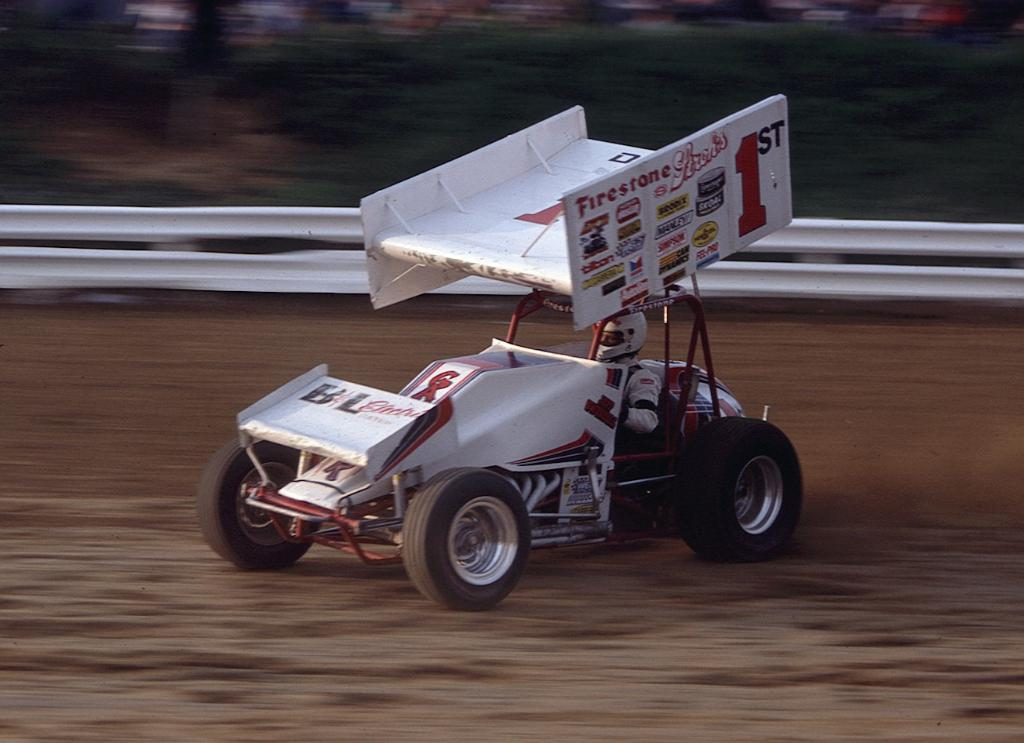<image>
Summarize the visual content of the image. a small car racing that is sponsored by Firestone 